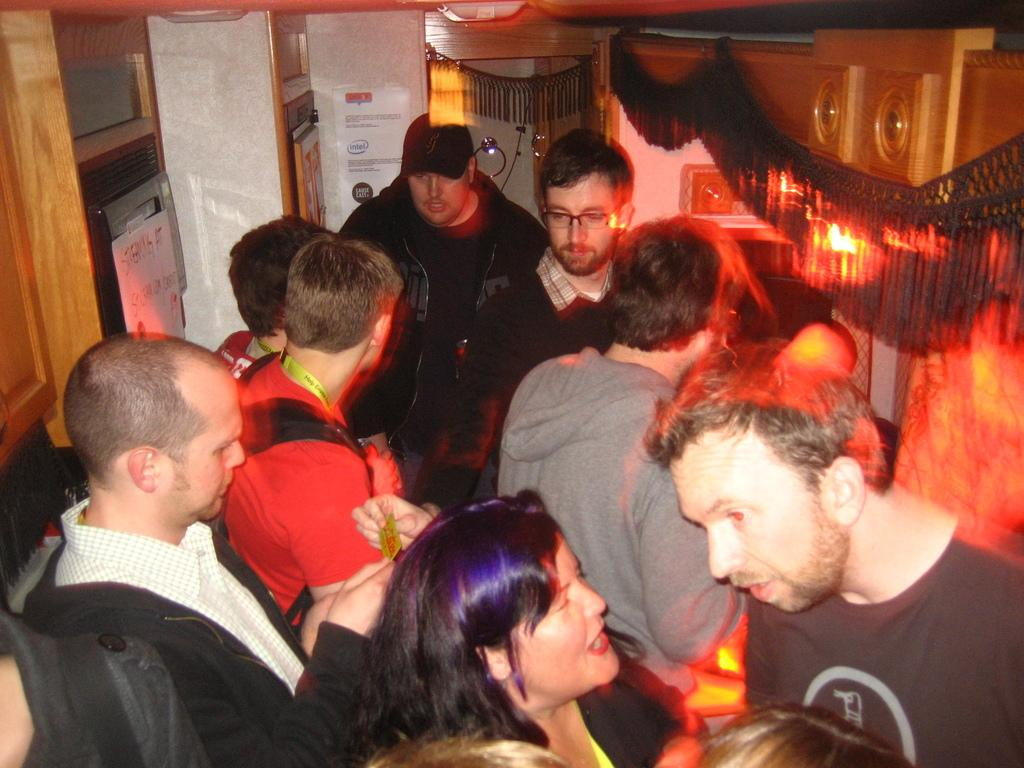What is the main subject of the image? There are people in the center of the image. What can be seen in the background of the image? There is a door in the background of the image. What architectural feature is present on the right side of the image? There is a wooden arch on the right side of the image. How many stalks of celery are being held by the rabbits in the image? There are no rabbits or celery present in the image. 